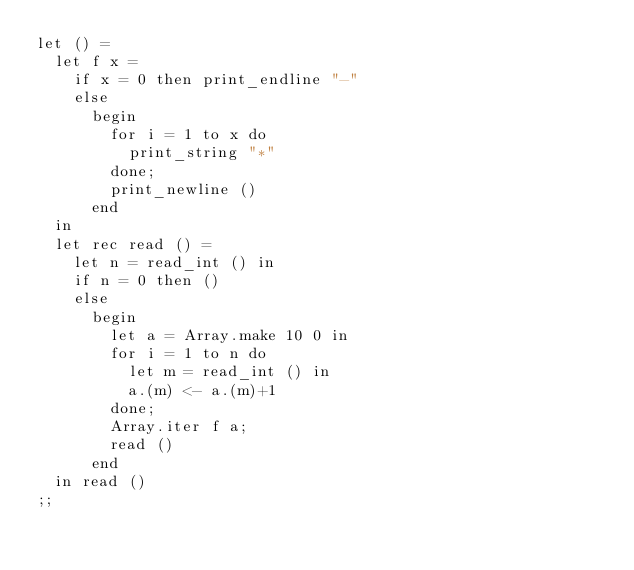<code> <loc_0><loc_0><loc_500><loc_500><_OCaml_>let () =
  let f x =
    if x = 0 then print_endline "-"
    else
      begin
        for i = 1 to x do
          print_string "*"
        done;
        print_newline ()
      end
  in
  let rec read () =
    let n = read_int () in
    if n = 0 then ()
    else
      begin
        let a = Array.make 10 0 in
        for i = 1 to n do
          let m = read_int () in
          a.(m) <- a.(m)+1
        done;
        Array.iter f a;
        read ()
      end
  in read ()
;;</code> 